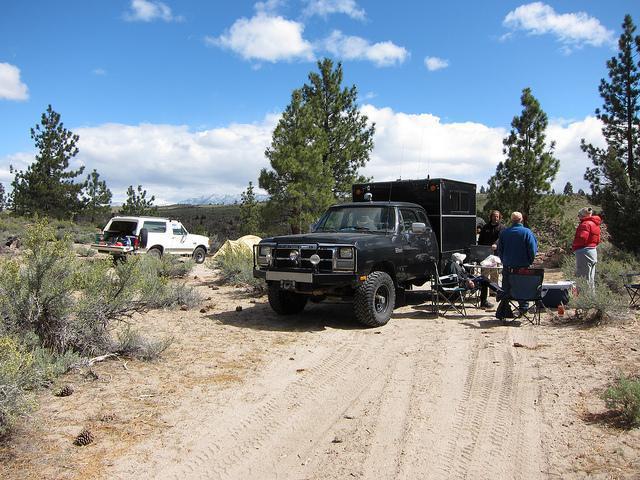How many vehicles are in the photo?
Give a very brief answer. 2. How many cars are in the picture?
Give a very brief answer. 2. How many trucks are in the picture?
Give a very brief answer. 2. 